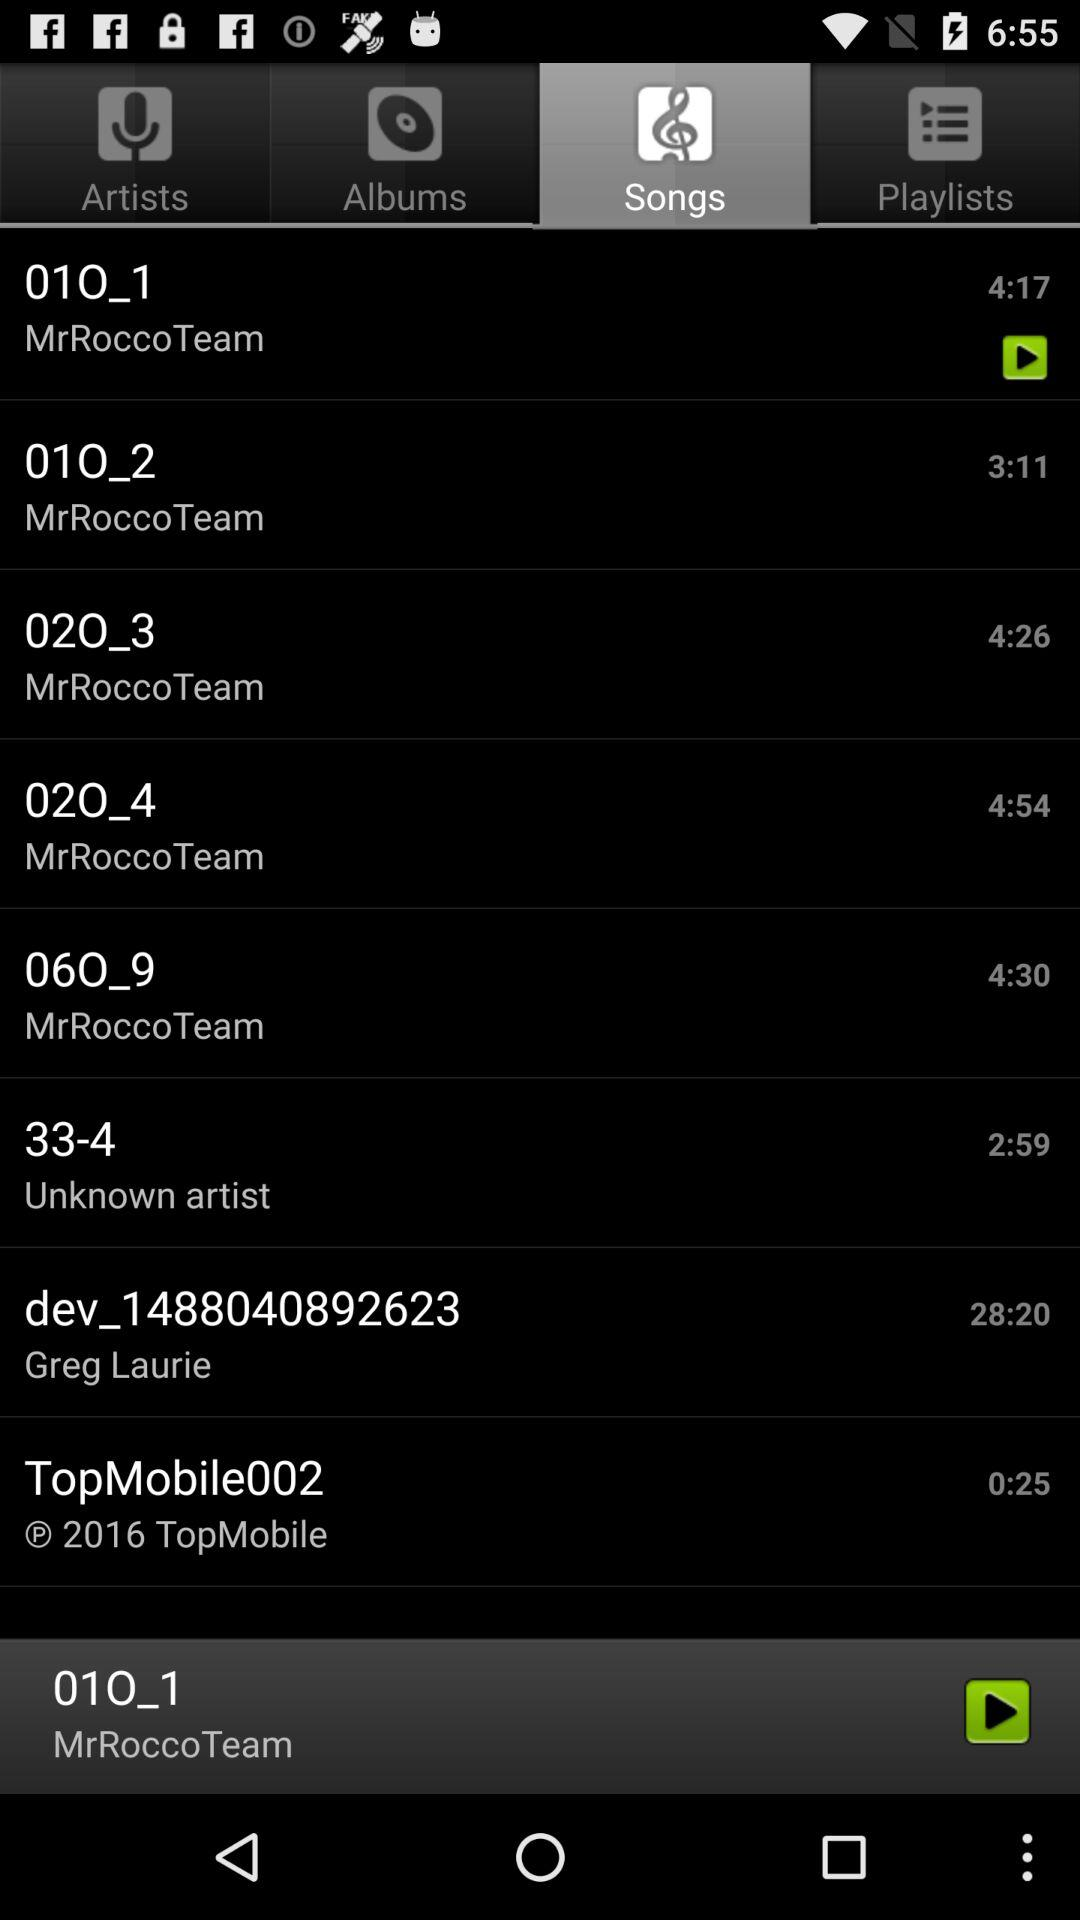What is the time duration of the song "01O_1"? The time duration of the song "01O_1" is 4 minutes 17 seconds. 